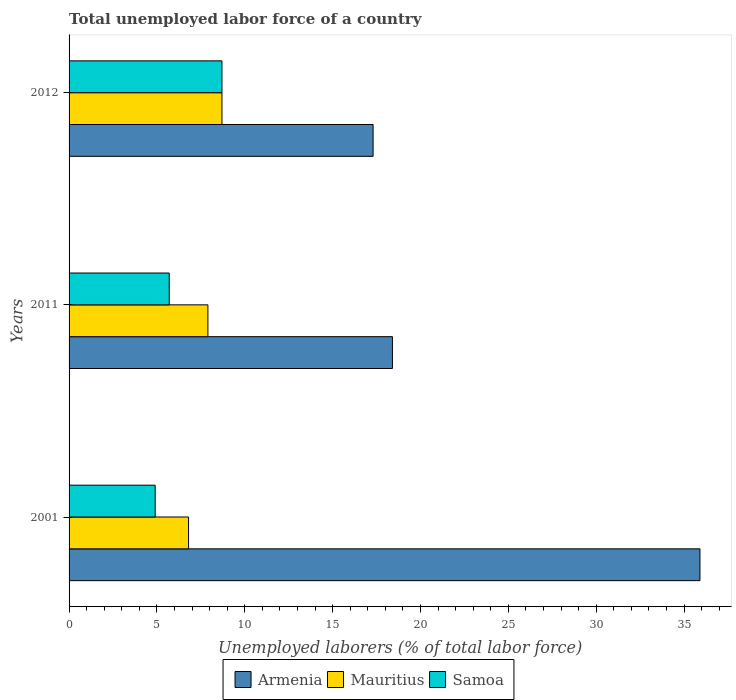How many different coloured bars are there?
Ensure brevity in your answer.  3. Are the number of bars per tick equal to the number of legend labels?
Ensure brevity in your answer.  Yes. How many bars are there on the 1st tick from the bottom?
Your answer should be compact. 3. What is the label of the 3rd group of bars from the top?
Your answer should be very brief. 2001. What is the total unemployed labor force in Mauritius in 2012?
Your response must be concise. 8.7. Across all years, what is the maximum total unemployed labor force in Mauritius?
Your answer should be very brief. 8.7. Across all years, what is the minimum total unemployed labor force in Armenia?
Keep it short and to the point. 17.3. What is the total total unemployed labor force in Armenia in the graph?
Provide a short and direct response. 71.6. What is the difference between the total unemployed labor force in Mauritius in 2001 and that in 2012?
Keep it short and to the point. -1.9. What is the difference between the total unemployed labor force in Armenia in 2001 and the total unemployed labor force in Samoa in 2012?
Keep it short and to the point. 27.2. What is the average total unemployed labor force in Samoa per year?
Your answer should be very brief. 6.43. In the year 2012, what is the difference between the total unemployed labor force in Mauritius and total unemployed labor force in Armenia?
Keep it short and to the point. -8.6. What is the ratio of the total unemployed labor force in Armenia in 2001 to that in 2012?
Your answer should be very brief. 2.08. Is the total unemployed labor force in Samoa in 2011 less than that in 2012?
Give a very brief answer. Yes. What is the difference between the highest and the second highest total unemployed labor force in Armenia?
Keep it short and to the point. 17.5. What is the difference between the highest and the lowest total unemployed labor force in Samoa?
Make the answer very short. 3.8. What does the 3rd bar from the top in 2001 represents?
Ensure brevity in your answer.  Armenia. What does the 1st bar from the bottom in 2001 represents?
Make the answer very short. Armenia. Is it the case that in every year, the sum of the total unemployed labor force in Samoa and total unemployed labor force in Armenia is greater than the total unemployed labor force in Mauritius?
Ensure brevity in your answer.  Yes. What is the difference between two consecutive major ticks on the X-axis?
Keep it short and to the point. 5. Are the values on the major ticks of X-axis written in scientific E-notation?
Your answer should be very brief. No. Where does the legend appear in the graph?
Give a very brief answer. Bottom center. How many legend labels are there?
Offer a terse response. 3. How are the legend labels stacked?
Keep it short and to the point. Horizontal. What is the title of the graph?
Offer a very short reply. Total unemployed labor force of a country. Does "Bahrain" appear as one of the legend labels in the graph?
Provide a short and direct response. No. What is the label or title of the X-axis?
Offer a very short reply. Unemployed laborers (% of total labor force). What is the Unemployed laborers (% of total labor force) of Armenia in 2001?
Offer a terse response. 35.9. What is the Unemployed laborers (% of total labor force) of Mauritius in 2001?
Offer a terse response. 6.8. What is the Unemployed laborers (% of total labor force) in Samoa in 2001?
Provide a short and direct response. 4.9. What is the Unemployed laborers (% of total labor force) in Armenia in 2011?
Provide a short and direct response. 18.4. What is the Unemployed laborers (% of total labor force) of Mauritius in 2011?
Provide a short and direct response. 7.9. What is the Unemployed laborers (% of total labor force) of Samoa in 2011?
Keep it short and to the point. 5.7. What is the Unemployed laborers (% of total labor force) in Armenia in 2012?
Your answer should be very brief. 17.3. What is the Unemployed laborers (% of total labor force) in Mauritius in 2012?
Provide a succinct answer. 8.7. What is the Unemployed laborers (% of total labor force) of Samoa in 2012?
Keep it short and to the point. 8.7. Across all years, what is the maximum Unemployed laborers (% of total labor force) of Armenia?
Offer a very short reply. 35.9. Across all years, what is the maximum Unemployed laborers (% of total labor force) of Mauritius?
Offer a terse response. 8.7. Across all years, what is the maximum Unemployed laborers (% of total labor force) of Samoa?
Your answer should be very brief. 8.7. Across all years, what is the minimum Unemployed laborers (% of total labor force) in Armenia?
Your answer should be compact. 17.3. Across all years, what is the minimum Unemployed laborers (% of total labor force) in Mauritius?
Offer a very short reply. 6.8. Across all years, what is the minimum Unemployed laborers (% of total labor force) in Samoa?
Your answer should be very brief. 4.9. What is the total Unemployed laborers (% of total labor force) in Armenia in the graph?
Keep it short and to the point. 71.6. What is the total Unemployed laborers (% of total labor force) of Mauritius in the graph?
Keep it short and to the point. 23.4. What is the total Unemployed laborers (% of total labor force) in Samoa in the graph?
Your answer should be compact. 19.3. What is the difference between the Unemployed laborers (% of total labor force) in Armenia in 2001 and that in 2011?
Keep it short and to the point. 17.5. What is the difference between the Unemployed laborers (% of total labor force) of Mauritius in 2001 and that in 2011?
Your response must be concise. -1.1. What is the difference between the Unemployed laborers (% of total labor force) in Samoa in 2001 and that in 2011?
Your response must be concise. -0.8. What is the difference between the Unemployed laborers (% of total labor force) in Armenia in 2001 and that in 2012?
Give a very brief answer. 18.6. What is the difference between the Unemployed laborers (% of total labor force) of Mauritius in 2001 and that in 2012?
Your response must be concise. -1.9. What is the difference between the Unemployed laborers (% of total labor force) of Mauritius in 2011 and that in 2012?
Ensure brevity in your answer.  -0.8. What is the difference between the Unemployed laborers (% of total labor force) in Armenia in 2001 and the Unemployed laborers (% of total labor force) in Mauritius in 2011?
Offer a terse response. 28. What is the difference between the Unemployed laborers (% of total labor force) in Armenia in 2001 and the Unemployed laborers (% of total labor force) in Samoa in 2011?
Your response must be concise. 30.2. What is the difference between the Unemployed laborers (% of total labor force) of Armenia in 2001 and the Unemployed laborers (% of total labor force) of Mauritius in 2012?
Make the answer very short. 27.2. What is the difference between the Unemployed laborers (% of total labor force) of Armenia in 2001 and the Unemployed laborers (% of total labor force) of Samoa in 2012?
Keep it short and to the point. 27.2. What is the difference between the Unemployed laborers (% of total labor force) of Mauritius in 2001 and the Unemployed laborers (% of total labor force) of Samoa in 2012?
Keep it short and to the point. -1.9. What is the difference between the Unemployed laborers (% of total labor force) of Armenia in 2011 and the Unemployed laborers (% of total labor force) of Mauritius in 2012?
Your answer should be very brief. 9.7. What is the difference between the Unemployed laborers (% of total labor force) in Armenia in 2011 and the Unemployed laborers (% of total labor force) in Samoa in 2012?
Make the answer very short. 9.7. What is the average Unemployed laborers (% of total labor force) in Armenia per year?
Keep it short and to the point. 23.87. What is the average Unemployed laborers (% of total labor force) of Samoa per year?
Ensure brevity in your answer.  6.43. In the year 2001, what is the difference between the Unemployed laborers (% of total labor force) of Armenia and Unemployed laborers (% of total labor force) of Mauritius?
Your answer should be compact. 29.1. In the year 2011, what is the difference between the Unemployed laborers (% of total labor force) in Armenia and Unemployed laborers (% of total labor force) in Mauritius?
Your answer should be compact. 10.5. In the year 2012, what is the difference between the Unemployed laborers (% of total labor force) in Armenia and Unemployed laborers (% of total labor force) in Samoa?
Your answer should be compact. 8.6. What is the ratio of the Unemployed laborers (% of total labor force) of Armenia in 2001 to that in 2011?
Make the answer very short. 1.95. What is the ratio of the Unemployed laborers (% of total labor force) in Mauritius in 2001 to that in 2011?
Provide a succinct answer. 0.86. What is the ratio of the Unemployed laborers (% of total labor force) of Samoa in 2001 to that in 2011?
Your answer should be compact. 0.86. What is the ratio of the Unemployed laborers (% of total labor force) in Armenia in 2001 to that in 2012?
Offer a terse response. 2.08. What is the ratio of the Unemployed laborers (% of total labor force) of Mauritius in 2001 to that in 2012?
Offer a very short reply. 0.78. What is the ratio of the Unemployed laborers (% of total labor force) in Samoa in 2001 to that in 2012?
Provide a short and direct response. 0.56. What is the ratio of the Unemployed laborers (% of total labor force) of Armenia in 2011 to that in 2012?
Your response must be concise. 1.06. What is the ratio of the Unemployed laborers (% of total labor force) in Mauritius in 2011 to that in 2012?
Give a very brief answer. 0.91. What is the ratio of the Unemployed laborers (% of total labor force) in Samoa in 2011 to that in 2012?
Provide a short and direct response. 0.66. What is the difference between the highest and the second highest Unemployed laborers (% of total labor force) of Armenia?
Keep it short and to the point. 17.5. What is the difference between the highest and the second highest Unemployed laborers (% of total labor force) in Samoa?
Offer a very short reply. 3. What is the difference between the highest and the lowest Unemployed laborers (% of total labor force) of Armenia?
Provide a succinct answer. 18.6. What is the difference between the highest and the lowest Unemployed laborers (% of total labor force) in Samoa?
Provide a short and direct response. 3.8. 